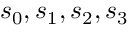<formula> <loc_0><loc_0><loc_500><loc_500>s _ { 0 } , s _ { 1 } , s _ { 2 } , s _ { 3 }</formula> 